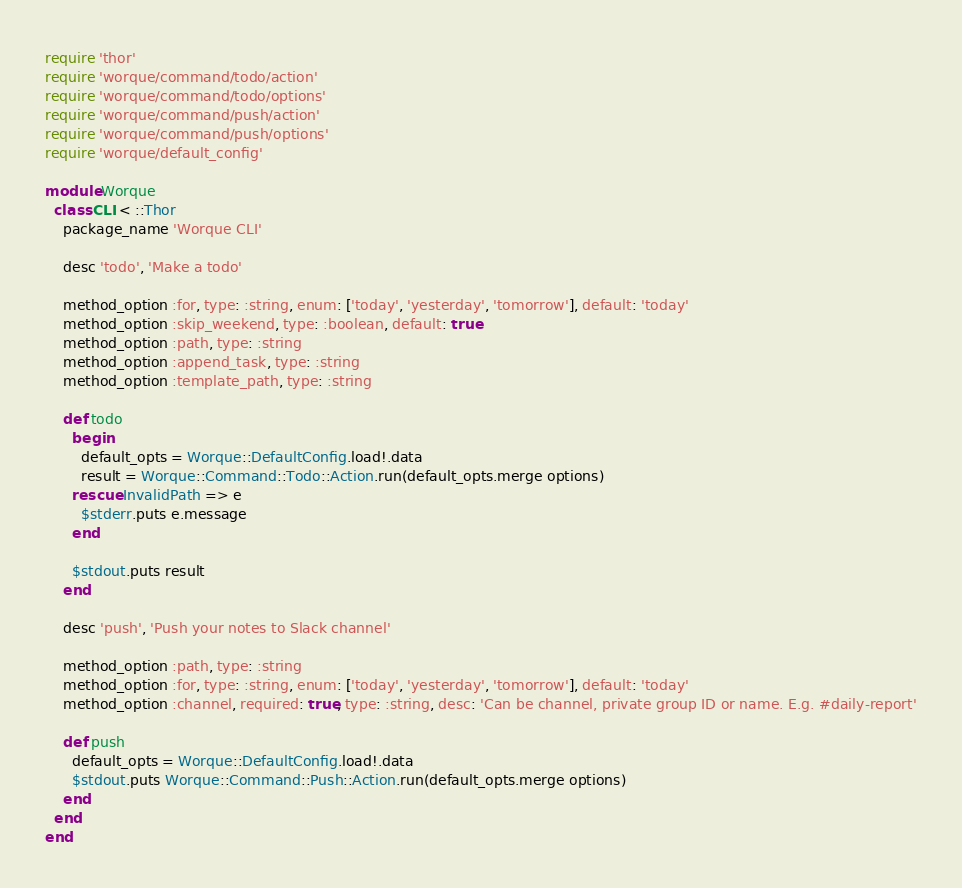<code> <loc_0><loc_0><loc_500><loc_500><_Ruby_>require 'thor'
require 'worque/command/todo/action'
require 'worque/command/todo/options'
require 'worque/command/push/action'
require 'worque/command/push/options'
require 'worque/default_config'

module Worque
  class CLI < ::Thor
    package_name 'Worque CLI'

    desc 'todo', 'Make a todo'

    method_option :for, type: :string, enum: ['today', 'yesterday', 'tomorrow'], default: 'today'
    method_option :skip_weekend, type: :boolean, default: true
    method_option :path, type: :string
    method_option :append_task, type: :string
    method_option :template_path, type: :string

    def todo
      begin
        default_opts = Worque::DefaultConfig.load!.data
        result = Worque::Command::Todo::Action.run(default_opts.merge options)
      rescue InvalidPath => e
        $stderr.puts e.message
      end

      $stdout.puts result
    end

    desc 'push', 'Push your notes to Slack channel'

    method_option :path, type: :string
    method_option :for, type: :string, enum: ['today', 'yesterday', 'tomorrow'], default: 'today'
    method_option :channel, required: true, type: :string, desc: 'Can be channel, private group ID or name. E.g. #daily-report'

    def push
      default_opts = Worque::DefaultConfig.load!.data
      $stdout.puts Worque::Command::Push::Action.run(default_opts.merge options)
    end
  end
end
</code> 